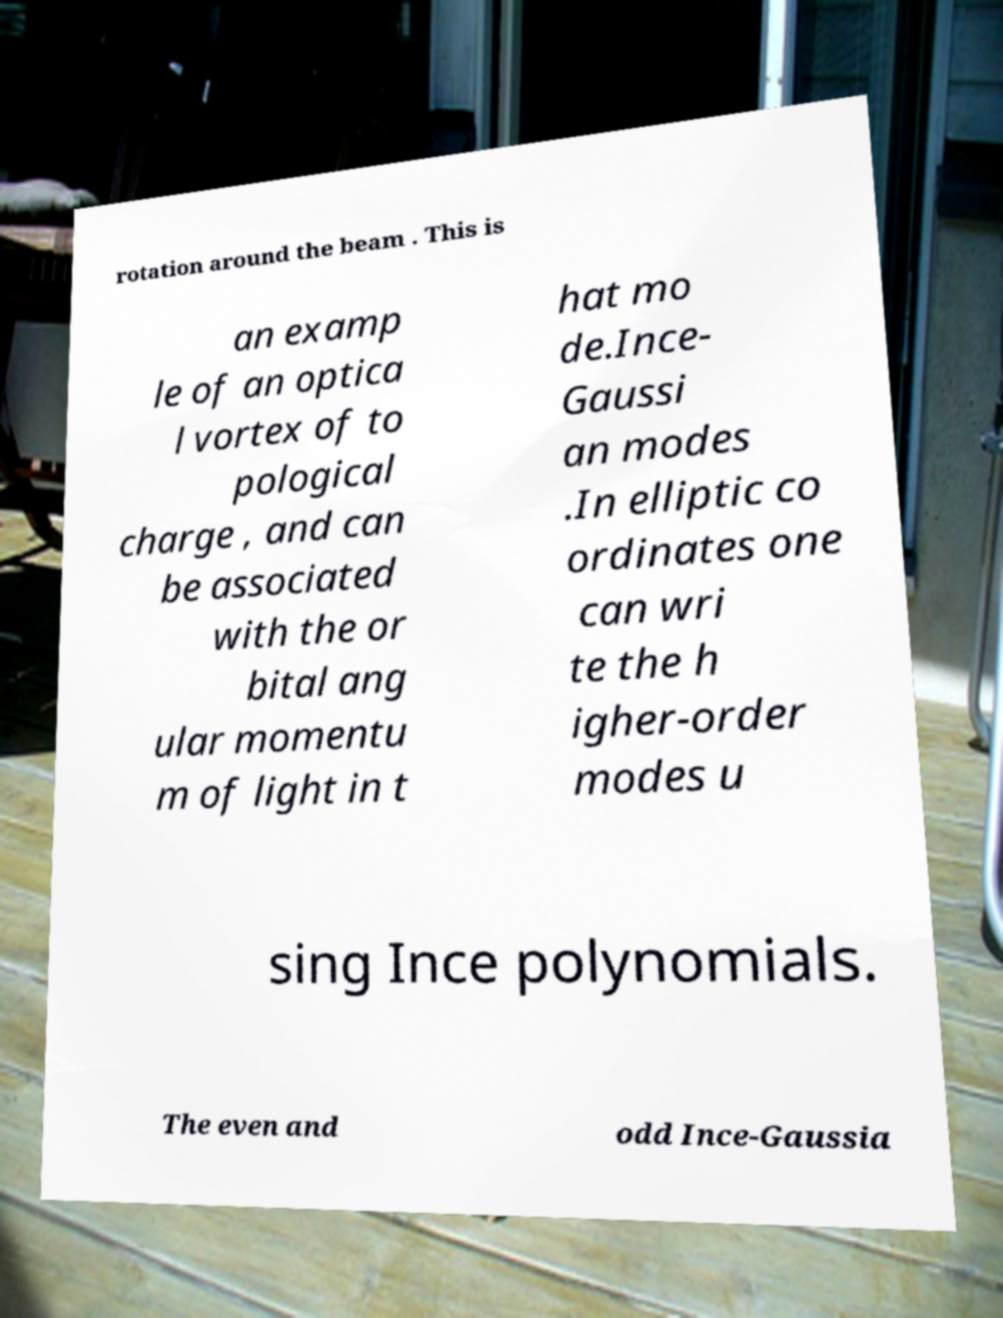I need the written content from this picture converted into text. Can you do that? rotation around the beam . This is an examp le of an optica l vortex of to pological charge , and can be associated with the or bital ang ular momentu m of light in t hat mo de.Ince- Gaussi an modes .In elliptic co ordinates one can wri te the h igher-order modes u sing Ince polynomials. The even and odd Ince-Gaussia 